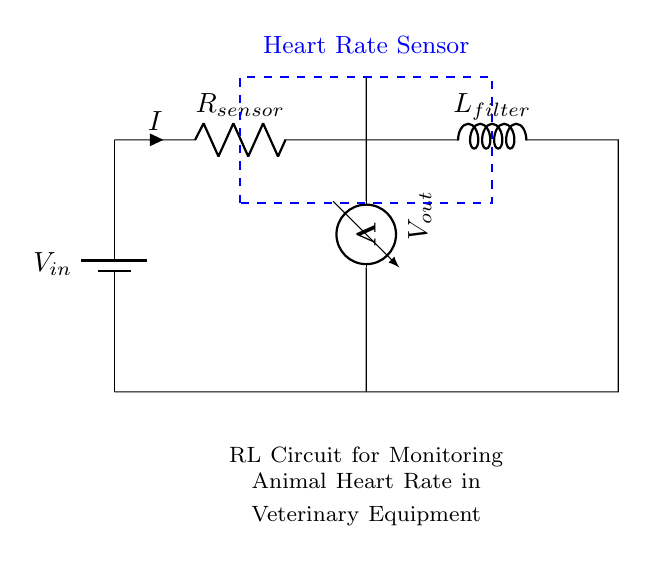What does the dashed rectangle represent? The dashed rectangle outlines the area where the heart rate sensor is located in the circuit. This visual indication helps identify the component associated with monitoring heart rates.
Answer: Heart Rate Sensor What is the current flowing through the resistor? The current is denoted as "I" in the circuit diagram, which indicates the flow of electric charge through the resistor. This current measurement is crucial for monitoring heart rates accurately.
Answer: I What is the component connected in series with the resistor? The inductor labeled as "L_filter" is connected in series after the resistor. This combination is essential for filtering and stabilizing the signals received from the heart rate sensor.
Answer: L_filter What does "V_out" represent? "V_out" refers to the voltage measured across the heart rate sensor. This output voltage is used for monitoring and analyzing the heart's electrical activities.
Answer: Voltage across heart rate sensor How does the inductor affect the current in this circuit? The inductor resists changes in current flow, which helps smooth out fluctuations in the current signal coming from the heart rate sensor. This property is important for providing stable readings of heart rates.
Answer: It smooths current What is the role of the resistor in this RL circuit? The resistor limits the current flowing through the circuit, protecting other components and ensuring that the heart rate sensor operates within safe parameters. It influences the overall voltage drop in the circuit.
Answer: Limits current What type of circuit is this? This is an RL circuit, which consists of a resistor and an inductor. It is specifically utilized for monitoring applications, such as capturing the heart rate in veterinary equipment.
Answer: RL Circuit 